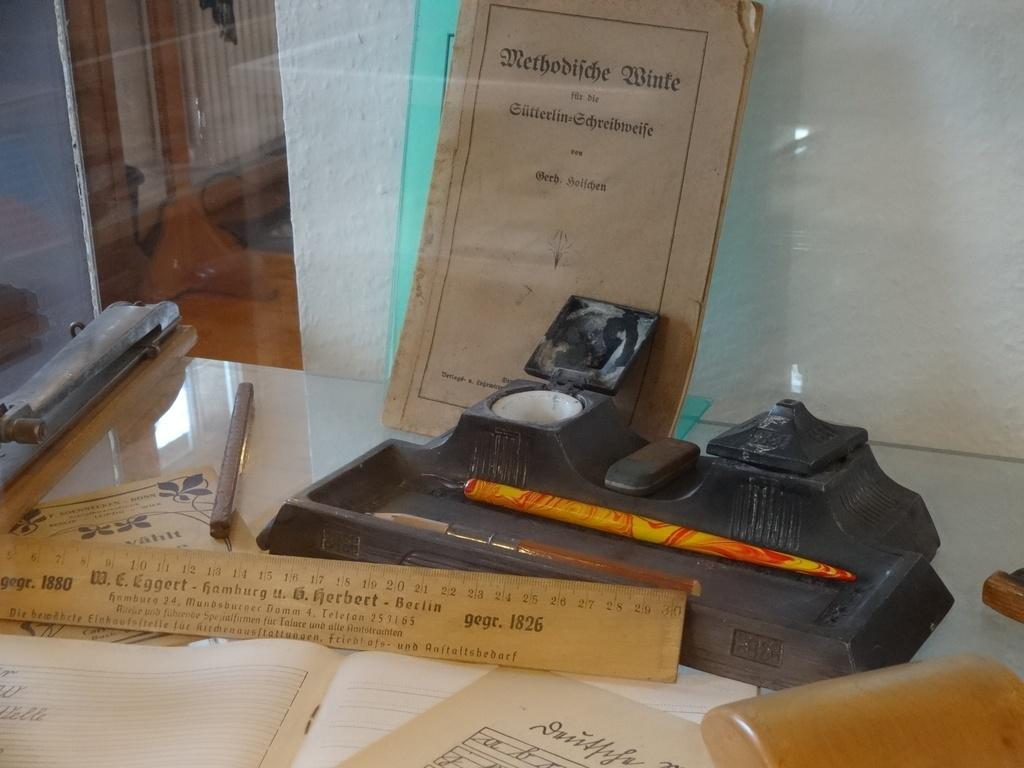<image>
Create a compact narrative representing the image presented. The ruler in the display case measures a little more than 30 cm. 